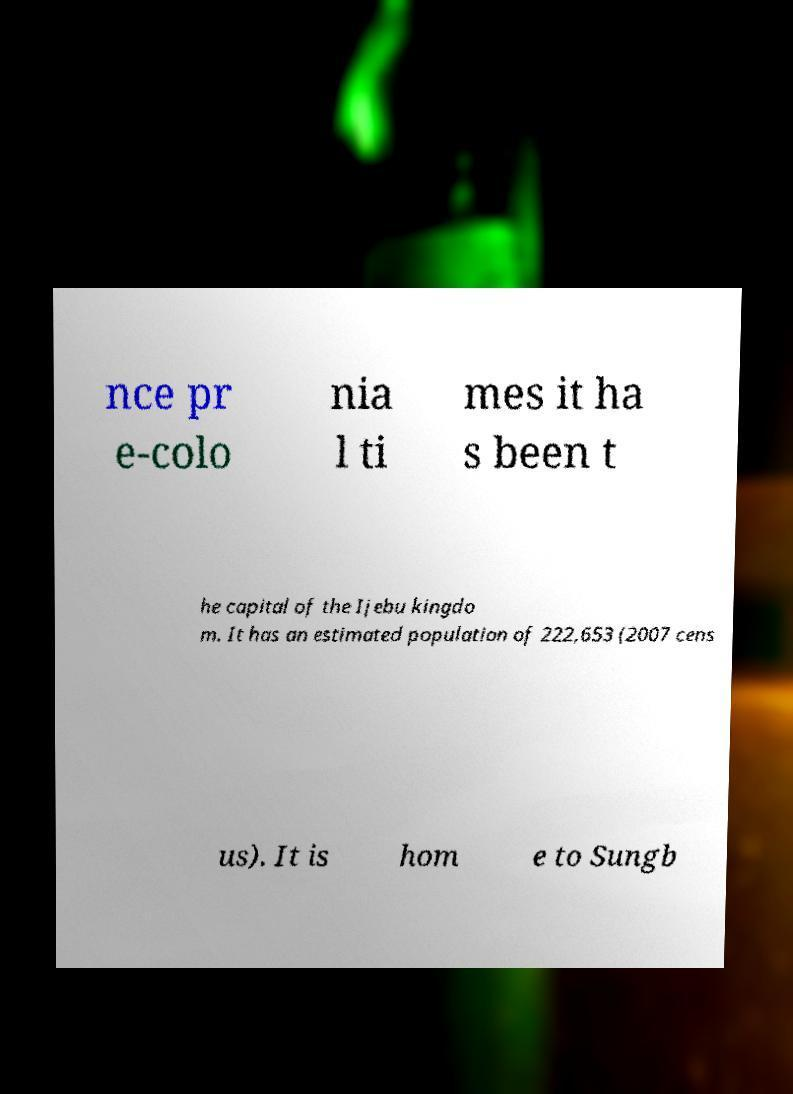For documentation purposes, I need the text within this image transcribed. Could you provide that? nce pr e-colo nia l ti mes it ha s been t he capital of the Ijebu kingdo m. It has an estimated population of 222,653 (2007 cens us). It is hom e to Sungb 